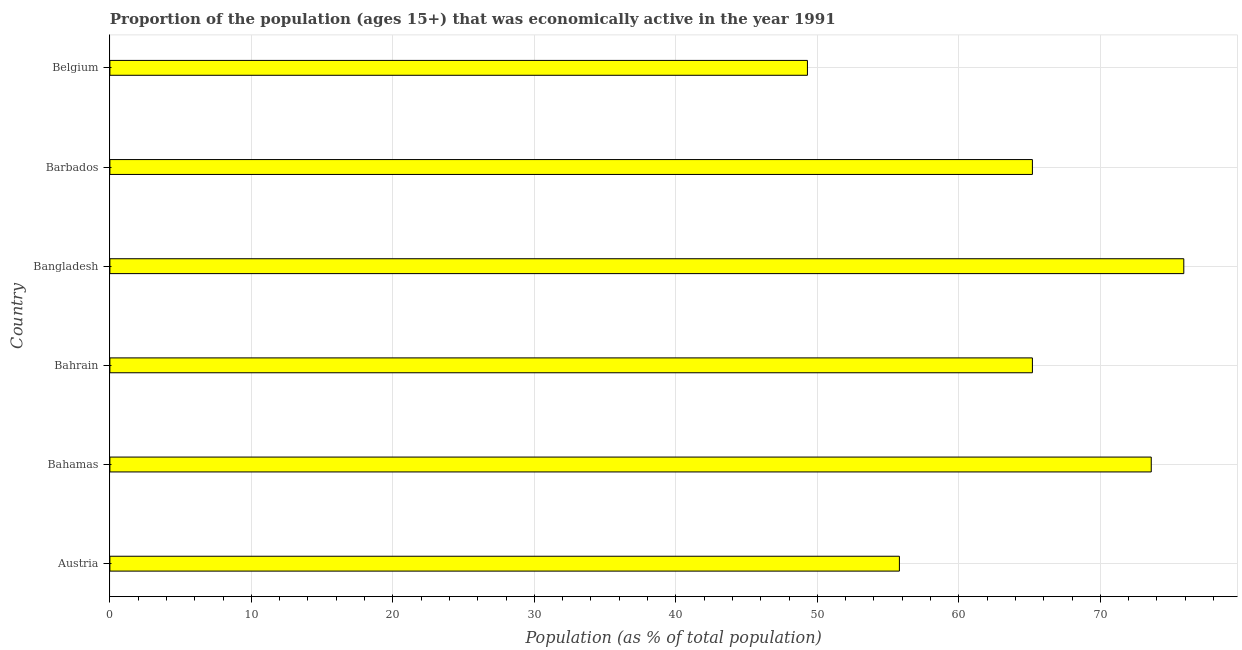Does the graph contain any zero values?
Your response must be concise. No. Does the graph contain grids?
Your answer should be compact. Yes. What is the title of the graph?
Provide a succinct answer. Proportion of the population (ages 15+) that was economically active in the year 1991. What is the label or title of the X-axis?
Offer a terse response. Population (as % of total population). What is the percentage of economically active population in Belgium?
Make the answer very short. 49.3. Across all countries, what is the maximum percentage of economically active population?
Your answer should be compact. 75.9. Across all countries, what is the minimum percentage of economically active population?
Your answer should be compact. 49.3. In which country was the percentage of economically active population minimum?
Offer a very short reply. Belgium. What is the sum of the percentage of economically active population?
Offer a very short reply. 385. What is the average percentage of economically active population per country?
Offer a terse response. 64.17. What is the median percentage of economically active population?
Your answer should be very brief. 65.2. In how many countries, is the percentage of economically active population greater than 46 %?
Ensure brevity in your answer.  6. What is the ratio of the percentage of economically active population in Austria to that in Bahamas?
Your answer should be compact. 0.76. Is the percentage of economically active population in Bahrain less than that in Bangladesh?
Keep it short and to the point. Yes. Is the difference between the percentage of economically active population in Bahamas and Bahrain greater than the difference between any two countries?
Your answer should be compact. No. What is the difference between the highest and the second highest percentage of economically active population?
Offer a terse response. 2.3. Is the sum of the percentage of economically active population in Austria and Bangladesh greater than the maximum percentage of economically active population across all countries?
Your answer should be compact. Yes. What is the difference between the highest and the lowest percentage of economically active population?
Give a very brief answer. 26.6. Are all the bars in the graph horizontal?
Ensure brevity in your answer.  Yes. Are the values on the major ticks of X-axis written in scientific E-notation?
Provide a short and direct response. No. What is the Population (as % of total population) in Austria?
Provide a succinct answer. 55.8. What is the Population (as % of total population) of Bahamas?
Offer a terse response. 73.6. What is the Population (as % of total population) of Bahrain?
Offer a terse response. 65.2. What is the Population (as % of total population) of Bangladesh?
Offer a very short reply. 75.9. What is the Population (as % of total population) of Barbados?
Offer a very short reply. 65.2. What is the Population (as % of total population) of Belgium?
Make the answer very short. 49.3. What is the difference between the Population (as % of total population) in Austria and Bahamas?
Your answer should be very brief. -17.8. What is the difference between the Population (as % of total population) in Austria and Bangladesh?
Provide a short and direct response. -20.1. What is the difference between the Population (as % of total population) in Bahamas and Bahrain?
Offer a very short reply. 8.4. What is the difference between the Population (as % of total population) in Bahamas and Belgium?
Keep it short and to the point. 24.3. What is the difference between the Population (as % of total population) in Bangladesh and Barbados?
Offer a terse response. 10.7. What is the difference between the Population (as % of total population) in Bangladesh and Belgium?
Make the answer very short. 26.6. What is the ratio of the Population (as % of total population) in Austria to that in Bahamas?
Keep it short and to the point. 0.76. What is the ratio of the Population (as % of total population) in Austria to that in Bahrain?
Your answer should be compact. 0.86. What is the ratio of the Population (as % of total population) in Austria to that in Bangladesh?
Give a very brief answer. 0.73. What is the ratio of the Population (as % of total population) in Austria to that in Barbados?
Your response must be concise. 0.86. What is the ratio of the Population (as % of total population) in Austria to that in Belgium?
Your answer should be very brief. 1.13. What is the ratio of the Population (as % of total population) in Bahamas to that in Bahrain?
Give a very brief answer. 1.13. What is the ratio of the Population (as % of total population) in Bahamas to that in Bangladesh?
Offer a very short reply. 0.97. What is the ratio of the Population (as % of total population) in Bahamas to that in Barbados?
Offer a terse response. 1.13. What is the ratio of the Population (as % of total population) in Bahamas to that in Belgium?
Give a very brief answer. 1.49. What is the ratio of the Population (as % of total population) in Bahrain to that in Bangladesh?
Provide a succinct answer. 0.86. What is the ratio of the Population (as % of total population) in Bahrain to that in Barbados?
Give a very brief answer. 1. What is the ratio of the Population (as % of total population) in Bahrain to that in Belgium?
Provide a succinct answer. 1.32. What is the ratio of the Population (as % of total population) in Bangladesh to that in Barbados?
Your answer should be very brief. 1.16. What is the ratio of the Population (as % of total population) in Bangladesh to that in Belgium?
Provide a succinct answer. 1.54. What is the ratio of the Population (as % of total population) in Barbados to that in Belgium?
Your response must be concise. 1.32. 